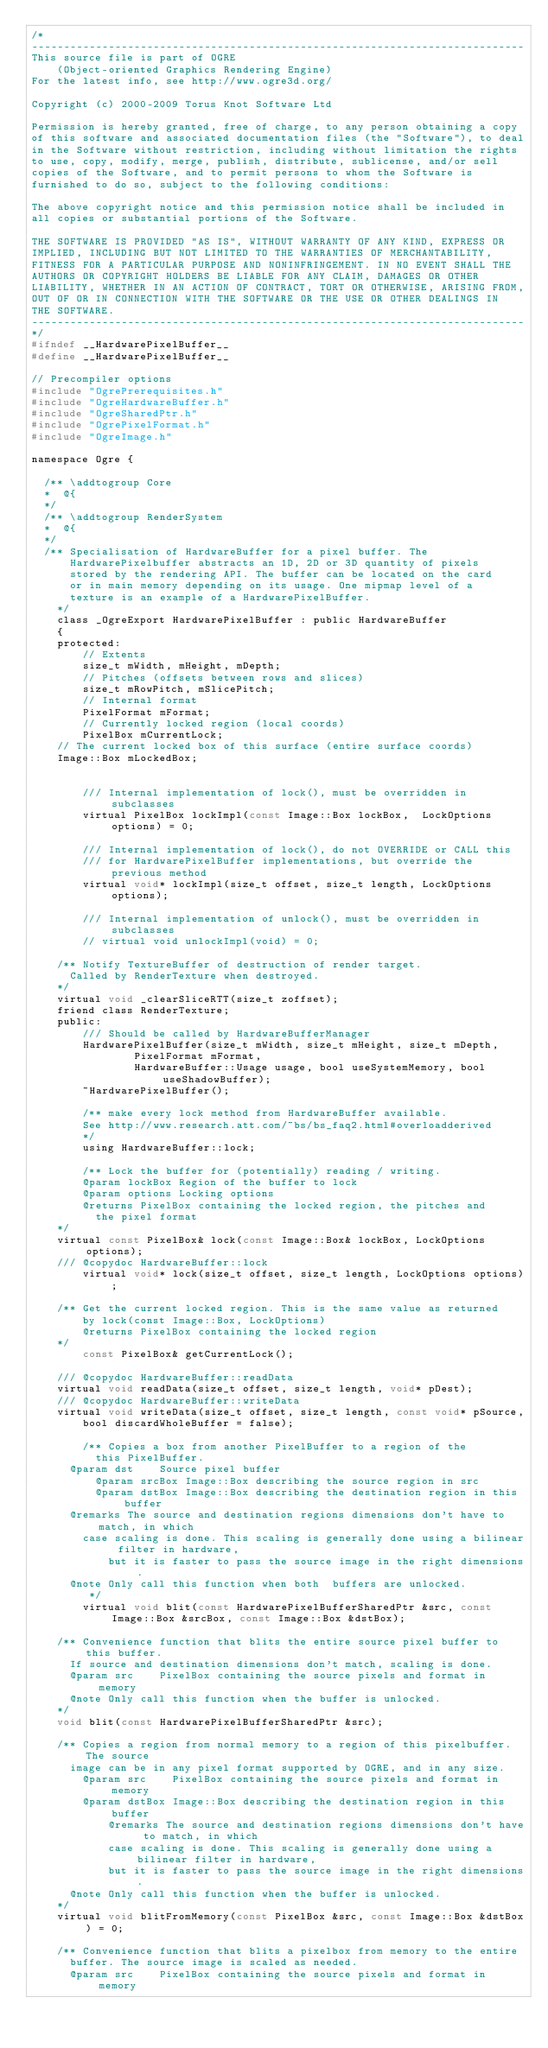Convert code to text. <code><loc_0><loc_0><loc_500><loc_500><_C_>/*
-----------------------------------------------------------------------------
This source file is part of OGRE
    (Object-oriented Graphics Rendering Engine)
For the latest info, see http://www.ogre3d.org/

Copyright (c) 2000-2009 Torus Knot Software Ltd

Permission is hereby granted, free of charge, to any person obtaining a copy
of this software and associated documentation files (the "Software"), to deal
in the Software without restriction, including without limitation the rights
to use, copy, modify, merge, publish, distribute, sublicense, and/or sell
copies of the Software, and to permit persons to whom the Software is
furnished to do so, subject to the following conditions:

The above copyright notice and this permission notice shall be included in
all copies or substantial portions of the Software.

THE SOFTWARE IS PROVIDED "AS IS", WITHOUT WARRANTY OF ANY KIND, EXPRESS OR
IMPLIED, INCLUDING BUT NOT LIMITED TO THE WARRANTIES OF MERCHANTABILITY,
FITNESS FOR A PARTICULAR PURPOSE AND NONINFRINGEMENT. IN NO EVENT SHALL THE
AUTHORS OR COPYRIGHT HOLDERS BE LIABLE FOR ANY CLAIM, DAMAGES OR OTHER
LIABILITY, WHETHER IN AN ACTION OF CONTRACT, TORT OR OTHERWISE, ARISING FROM,
OUT OF OR IN CONNECTION WITH THE SOFTWARE OR THE USE OR OTHER DEALINGS IN
THE SOFTWARE.
-----------------------------------------------------------------------------
*/
#ifndef __HardwarePixelBuffer__
#define __HardwarePixelBuffer__

// Precompiler options
#include "OgrePrerequisites.h"
#include "OgreHardwareBuffer.h"
#include "OgreSharedPtr.h"
#include "OgrePixelFormat.h"
#include "OgreImage.h"

namespace Ogre {

	/** \addtogroup Core
	*  @{
	*/
	/** \addtogroup RenderSystem
	*  @{
	*/
	/** Specialisation of HardwareBuffer for a pixel buffer. The
    	HardwarePixelbuffer abstracts an 1D, 2D or 3D quantity of pixels
    	stored by the rendering API. The buffer can be located on the card
    	or in main memory depending on its usage. One mipmap level of a
    	texture is an example of a HardwarePixelBuffer.
    */
    class _OgreExport HardwarePixelBuffer : public HardwareBuffer
    {
    protected: 
        // Extents
        size_t mWidth, mHeight, mDepth;
        // Pitches (offsets between rows and slices)
        size_t mRowPitch, mSlicePitch;
        // Internal format
        PixelFormat mFormat;
        // Currently locked region (local coords)
        PixelBox mCurrentLock;
		// The current locked box of this surface (entire surface coords)
		Image::Box mLockedBox;

        
        /// Internal implementation of lock(), must be overridden in subclasses
        virtual PixelBox lockImpl(const Image::Box lockBox,  LockOptions options) = 0;

        /// Internal implementation of lock(), do not OVERRIDE or CALL this
        /// for HardwarePixelBuffer implementations, but override the previous method
        virtual void* lockImpl(size_t offset, size_t length, LockOptions options);

        /// Internal implementation of unlock(), must be overridden in subclasses
        // virtual void unlockImpl(void) = 0;

		/** Notify TextureBuffer of destruction of render target.
			Called by RenderTexture when destroyed.
		*/
		virtual void _clearSliceRTT(size_t zoffset);
		friend class RenderTexture;
    public:
        /// Should be called by HardwareBufferManager
        HardwarePixelBuffer(size_t mWidth, size_t mHeight, size_t mDepth,
                PixelFormat mFormat,
                HardwareBuffer::Usage usage, bool useSystemMemory, bool useShadowBuffer);
        ~HardwarePixelBuffer();

        /** make every lock method from HardwareBuffer available.
        See http://www.research.att.com/~bs/bs_faq2.html#overloadderived
        */
        using HardwareBuffer::lock;	

        /** Lock the buffer for (potentially) reading / writing.
		    @param lockBox Region of the buffer to lock
		    @param options Locking options
		    @returns PixelBox containing the locked region, the pitches and
		    	the pixel format
		*/
		virtual const PixelBox& lock(const Image::Box& lockBox, LockOptions options);
		/// @copydoc HardwareBuffer::lock
        virtual void* lock(size_t offset, size_t length, LockOptions options);

		/** Get the current locked region. This is the same value as returned
		    by lock(const Image::Box, LockOptions)
		    @returns PixelBox containing the locked region
		*/        
        const PixelBox& getCurrentLock();
		
		/// @copydoc HardwareBuffer::readData
		virtual void readData(size_t offset, size_t length, void* pDest);
		/// @copydoc HardwareBuffer::writeData
		virtual void writeData(size_t offset, size_t length, const void* pSource,
				bool discardWholeBuffer = false);
        
        /** Copies a box from another PixelBuffer to a region of the 
        	this PixelBuffer. 
			@param dst		Source pixel buffer
        	@param srcBox	Image::Box describing the source region in src
        	@param dstBox	Image::Box describing the destination region in this buffer
			@remarks The source and destination regions dimensions don't have to match, in which
		   	case scaling is done. This scaling is generally done using a bilinear filter in hardware,
            but it is faster to pass the source image in the right dimensions.
			@note Only call this function when both  buffers are unlocked. 
         */        
        virtual void blit(const HardwarePixelBufferSharedPtr &src, const Image::Box &srcBox, const Image::Box &dstBox);

		/** Convenience function that blits the entire source pixel buffer to this buffer. 
			If source and destination dimensions don't match, scaling is done.
			@param src		PixelBox containing the source pixels and format in memory
			@note Only call this function when the buffer is unlocked. 
		*/
		void blit(const HardwarePixelBufferSharedPtr &src); 
		
		/** Copies a region from normal memory to a region of this pixelbuffer. The source
			image can be in any pixel format supported by OGRE, and in any size. 
		   	@param src		PixelBox containing the source pixels and format in memory
		   	@param dstBox	Image::Box describing the destination region in this buffer
            @remarks The source and destination regions dimensions don't have to match, in which
            case scaling is done. This scaling is generally done using a bilinear filter in hardware,
            but it is faster to pass the source image in the right dimensions.
			@note Only call this function when the buffer is unlocked. 
		*/
		virtual void blitFromMemory(const PixelBox &src, const Image::Box &dstBox) = 0;
		
		/** Convenience function that blits a pixelbox from memory to the entire 
			buffer. The source image is scaled as needed.
			@param src		PixelBox containing the source pixels and format in memory</code> 